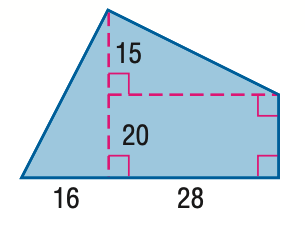Question: Find the area of the figure. Round to the nearest tenth, if necessary.
Choices:
A. 740
B. 840
C. 1050
D. 1540
Answer with the letter. Answer: C 